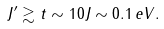<formula> <loc_0><loc_0><loc_500><loc_500>J ^ { \prime } \gtrsim t \sim 1 0 J \sim 0 . 1 \, e { V } .</formula> 